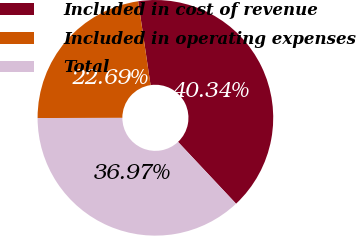Convert chart. <chart><loc_0><loc_0><loc_500><loc_500><pie_chart><fcel>Included in cost of revenue<fcel>Included in operating expenses<fcel>Total<nl><fcel>40.34%<fcel>22.69%<fcel>36.97%<nl></chart> 